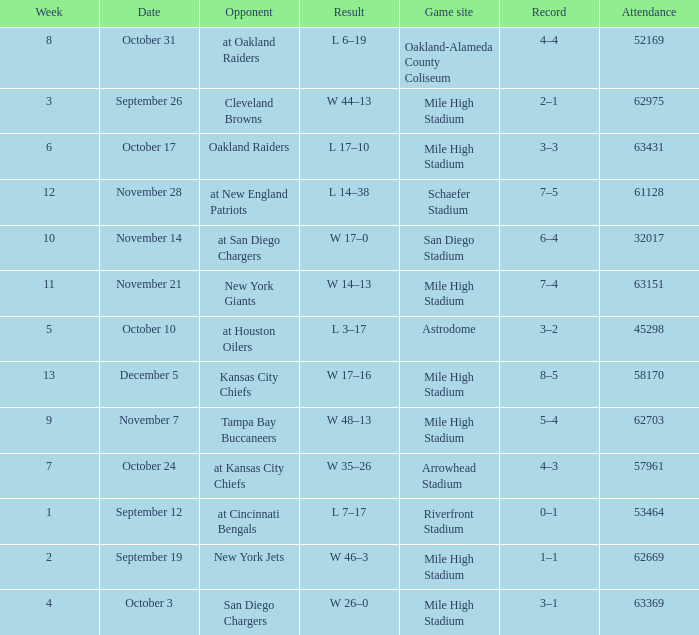What was the date of the week 4 game? October 3. 